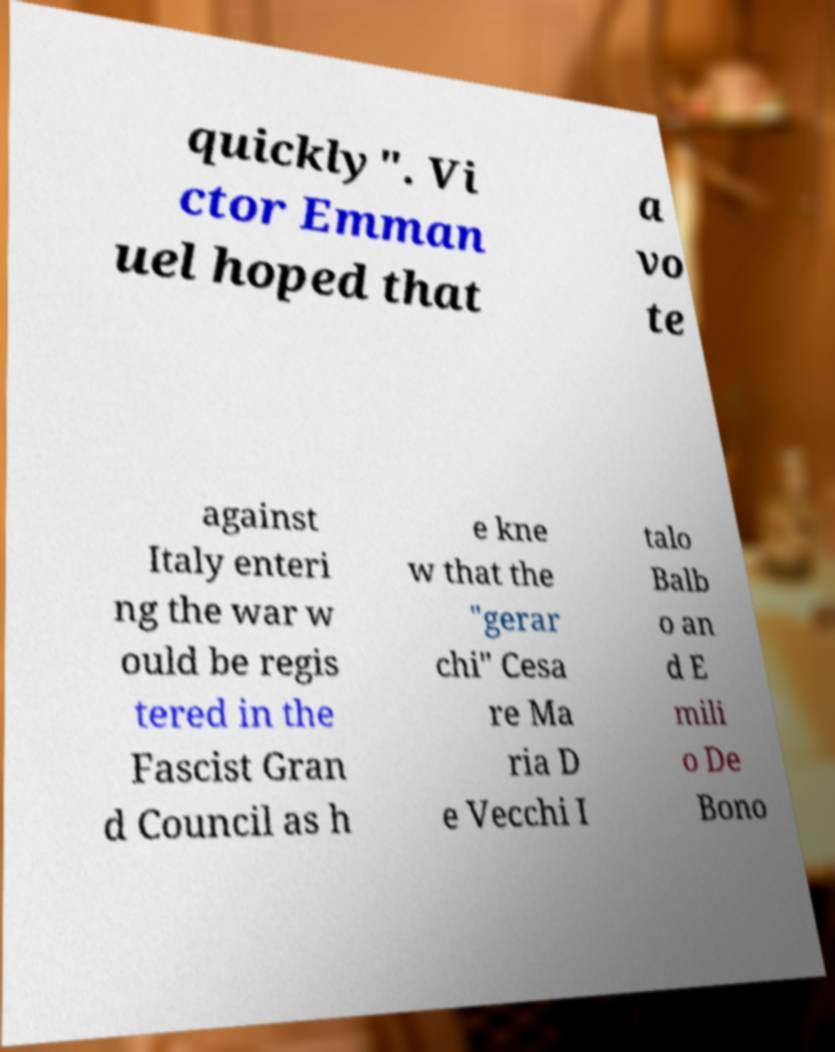For documentation purposes, I need the text within this image transcribed. Could you provide that? quickly". Vi ctor Emman uel hoped that a vo te against Italy enteri ng the war w ould be regis tered in the Fascist Gran d Council as h e kne w that the "gerar chi" Cesa re Ma ria D e Vecchi I talo Balb o an d E mili o De Bono 